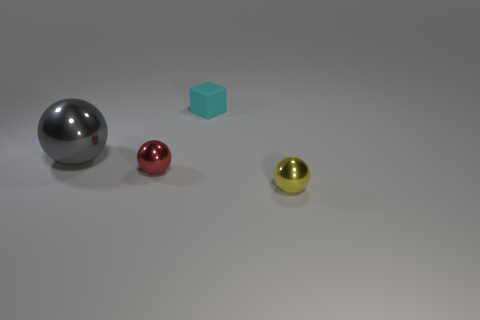What is the color of the rubber block that is the same size as the red shiny thing?
Give a very brief answer. Cyan. Is there a rubber cylinder of the same color as the tiny block?
Make the answer very short. No. Is the number of yellow objects that are in front of the large gray metallic sphere less than the number of small shiny spheres left of the cyan matte thing?
Ensure brevity in your answer.  No. There is a object that is in front of the cyan rubber thing and on the right side of the red metal thing; what is its material?
Provide a short and direct response. Metal. Does the yellow metal object have the same shape as the metal thing left of the red shiny sphere?
Provide a succinct answer. Yes. What number of other objects are the same size as the cyan rubber cube?
Your answer should be compact. 2. Are there more large red metallic cubes than small metallic objects?
Your answer should be compact. No. What number of things are both on the right side of the large shiny ball and behind the yellow thing?
Give a very brief answer. 2. What is the shape of the thing that is to the right of the rubber block left of the sphere on the right side of the cyan cube?
Keep it short and to the point. Sphere. Is there any other thing that is the same shape as the tiny matte object?
Ensure brevity in your answer.  No. 